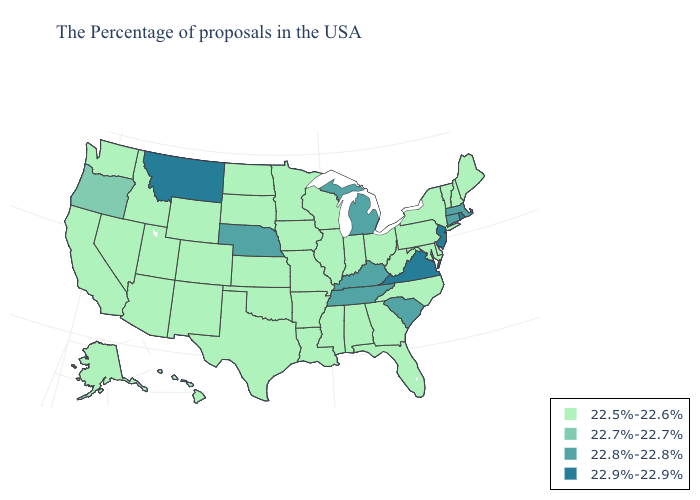What is the value of Idaho?
Concise answer only. 22.5%-22.6%. Which states have the highest value in the USA?
Quick response, please. Rhode Island, New Jersey, Virginia, Montana. Name the states that have a value in the range 22.9%-22.9%?
Keep it brief. Rhode Island, New Jersey, Virginia, Montana. What is the lowest value in the Northeast?
Be succinct. 22.5%-22.6%. What is the value of Arizona?
Write a very short answer. 22.5%-22.6%. Does the first symbol in the legend represent the smallest category?
Give a very brief answer. Yes. What is the highest value in the USA?
Give a very brief answer. 22.9%-22.9%. What is the lowest value in states that border Montana?
Short answer required. 22.5%-22.6%. Name the states that have a value in the range 22.9%-22.9%?
Give a very brief answer. Rhode Island, New Jersey, Virginia, Montana. What is the value of Massachusetts?
Give a very brief answer. 22.8%-22.8%. What is the value of Oregon?
Short answer required. 22.7%-22.7%. Among the states that border Missouri , which have the highest value?
Concise answer only. Kentucky, Tennessee, Nebraska. Is the legend a continuous bar?
Quick response, please. No. How many symbols are there in the legend?
Keep it brief. 4. Is the legend a continuous bar?
Keep it brief. No. 